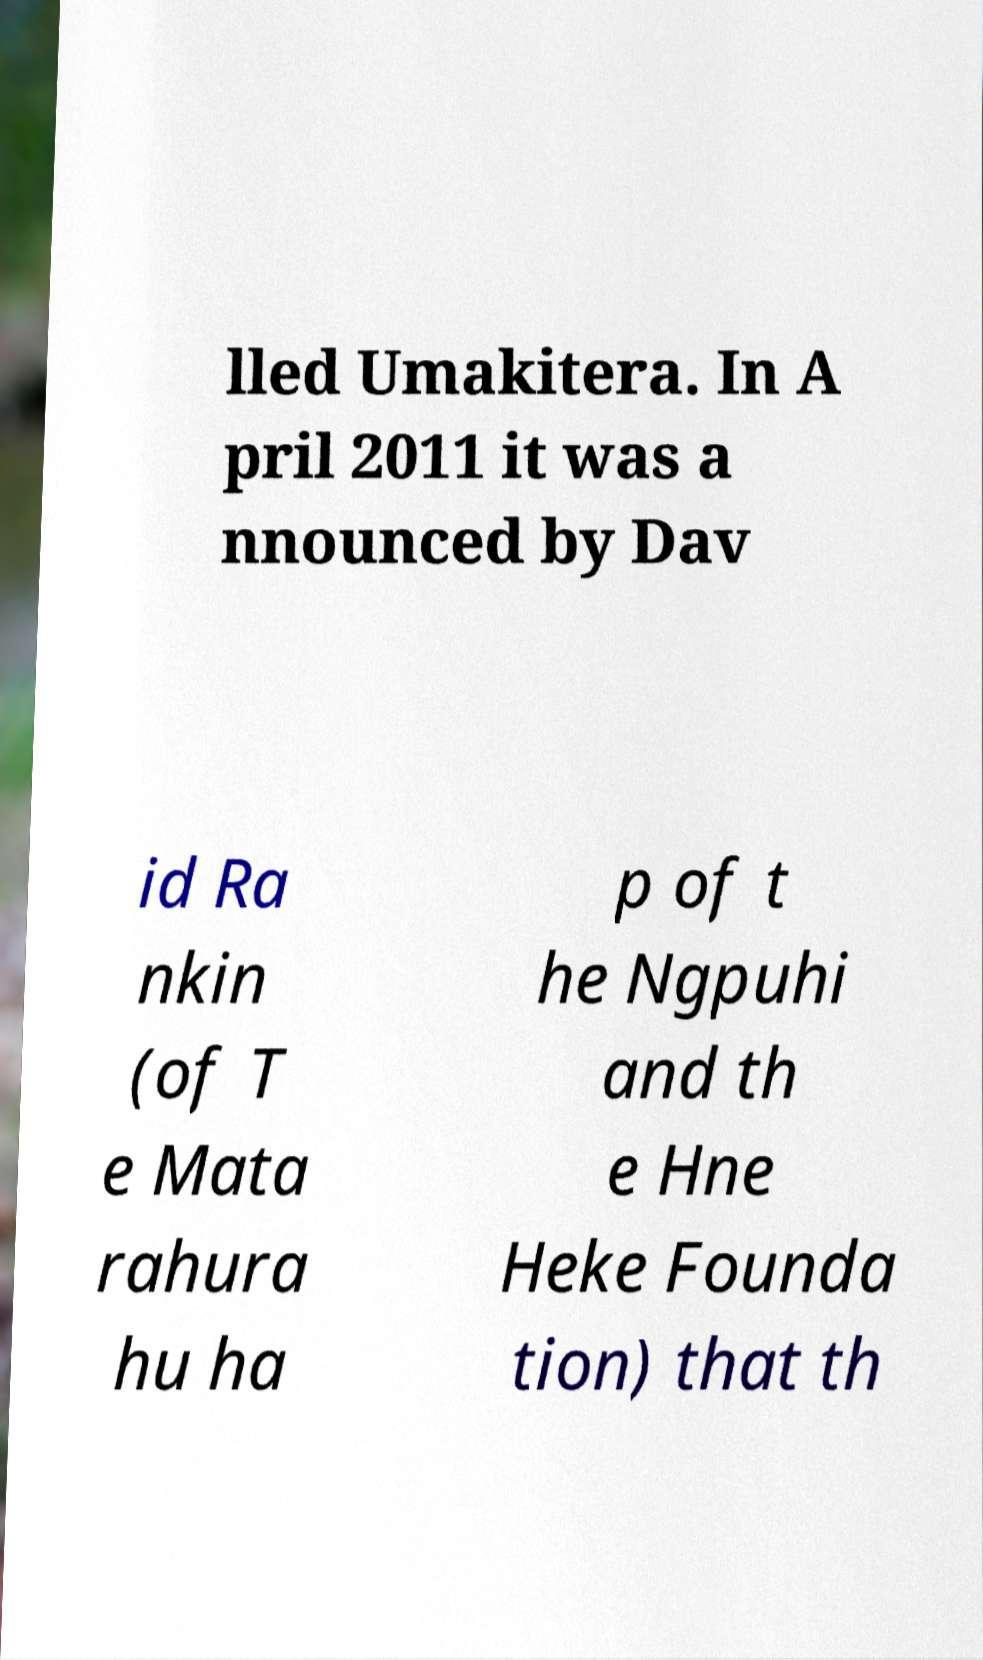For documentation purposes, I need the text within this image transcribed. Could you provide that? lled Umakitera. In A pril 2011 it was a nnounced by Dav id Ra nkin (of T e Mata rahura hu ha p of t he Ngpuhi and th e Hne Heke Founda tion) that th 